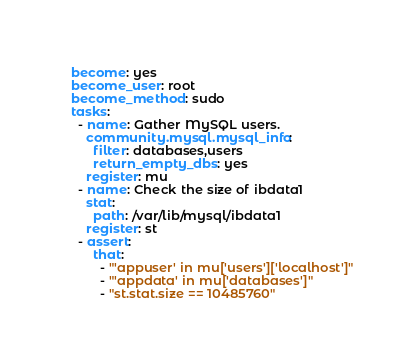Convert code to text. <code><loc_0><loc_0><loc_500><loc_500><_YAML_>  become: yes
  become_user: root
  become_method: sudo
  tasks:
    - name: Gather MySQL users.
      community.mysql.mysql_info:
        filter: databases,users
        return_empty_dbs: yes
      register: mu
    - name: Check the size of ibdata1
      stat:
        path: /var/lib/mysql/ibdata1
      register: st
    - assert:
        that:
          - "'appuser' in mu['users']['localhost']"
          - "'appdata' in mu['databases']"
          - "st.stat.size == 10485760"
</code> 